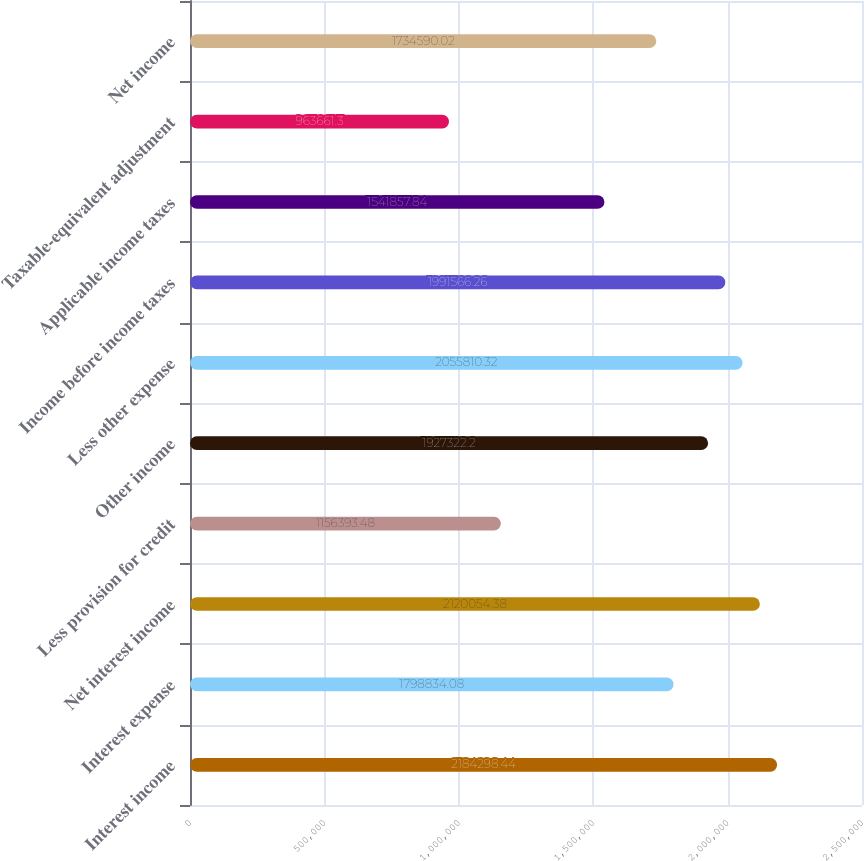Convert chart. <chart><loc_0><loc_0><loc_500><loc_500><bar_chart><fcel>Interest income<fcel>Interest expense<fcel>Net interest income<fcel>Less provision for credit<fcel>Other income<fcel>Less other expense<fcel>Income before income taxes<fcel>Applicable income taxes<fcel>Taxable-equivalent adjustment<fcel>Net income<nl><fcel>2.1843e+06<fcel>1.79883e+06<fcel>2.12005e+06<fcel>1.15639e+06<fcel>1.92732e+06<fcel>2.05581e+06<fcel>1.99157e+06<fcel>1.54186e+06<fcel>963661<fcel>1.73459e+06<nl></chart> 